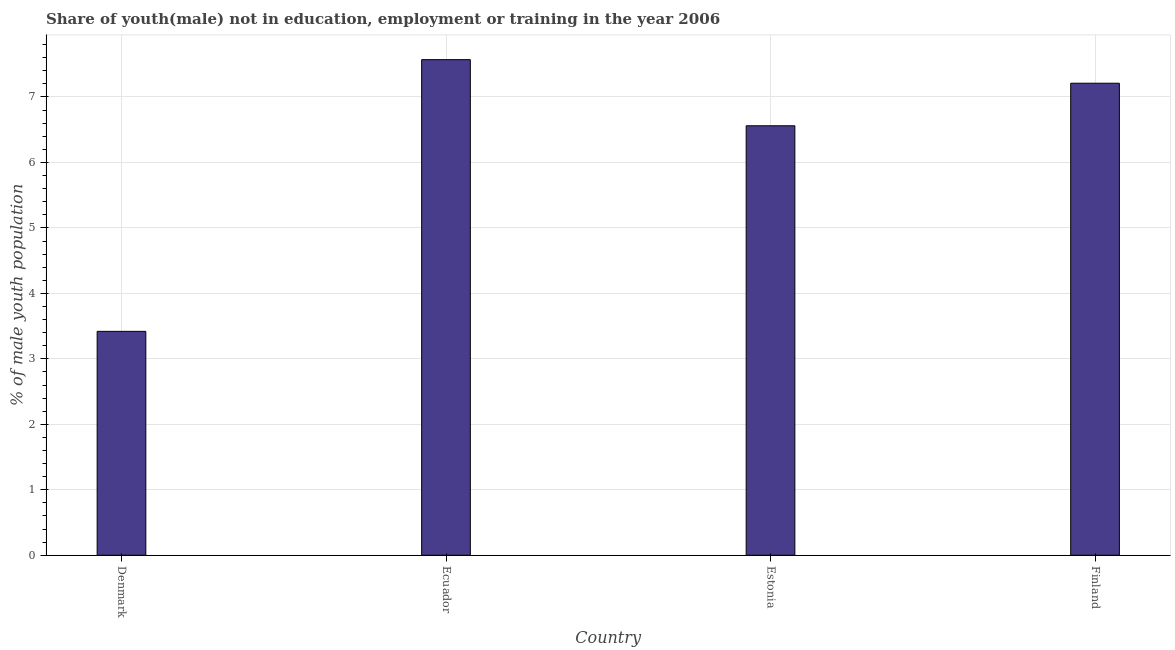Does the graph contain grids?
Give a very brief answer. Yes. What is the title of the graph?
Provide a succinct answer. Share of youth(male) not in education, employment or training in the year 2006. What is the label or title of the X-axis?
Provide a succinct answer. Country. What is the label or title of the Y-axis?
Offer a terse response. % of male youth population. What is the unemployed male youth population in Estonia?
Make the answer very short. 6.56. Across all countries, what is the maximum unemployed male youth population?
Provide a succinct answer. 7.57. Across all countries, what is the minimum unemployed male youth population?
Your answer should be compact. 3.42. In which country was the unemployed male youth population maximum?
Your answer should be compact. Ecuador. In which country was the unemployed male youth population minimum?
Your answer should be compact. Denmark. What is the sum of the unemployed male youth population?
Your response must be concise. 24.76. What is the difference between the unemployed male youth population in Ecuador and Finland?
Ensure brevity in your answer.  0.36. What is the average unemployed male youth population per country?
Offer a very short reply. 6.19. What is the median unemployed male youth population?
Give a very brief answer. 6.88. What is the ratio of the unemployed male youth population in Ecuador to that in Finland?
Keep it short and to the point. 1.05. Is the difference between the unemployed male youth population in Ecuador and Estonia greater than the difference between any two countries?
Your answer should be compact. No. What is the difference between the highest and the second highest unemployed male youth population?
Your answer should be very brief. 0.36. Is the sum of the unemployed male youth population in Ecuador and Finland greater than the maximum unemployed male youth population across all countries?
Your answer should be compact. Yes. What is the difference between the highest and the lowest unemployed male youth population?
Your answer should be compact. 4.15. In how many countries, is the unemployed male youth population greater than the average unemployed male youth population taken over all countries?
Your answer should be very brief. 3. Are the values on the major ticks of Y-axis written in scientific E-notation?
Offer a very short reply. No. What is the % of male youth population in Denmark?
Your answer should be very brief. 3.42. What is the % of male youth population in Ecuador?
Give a very brief answer. 7.57. What is the % of male youth population in Estonia?
Ensure brevity in your answer.  6.56. What is the % of male youth population in Finland?
Offer a terse response. 7.21. What is the difference between the % of male youth population in Denmark and Ecuador?
Your answer should be very brief. -4.15. What is the difference between the % of male youth population in Denmark and Estonia?
Your answer should be very brief. -3.14. What is the difference between the % of male youth population in Denmark and Finland?
Provide a succinct answer. -3.79. What is the difference between the % of male youth population in Ecuador and Estonia?
Your response must be concise. 1.01. What is the difference between the % of male youth population in Ecuador and Finland?
Your answer should be very brief. 0.36. What is the difference between the % of male youth population in Estonia and Finland?
Your response must be concise. -0.65. What is the ratio of the % of male youth population in Denmark to that in Ecuador?
Ensure brevity in your answer.  0.45. What is the ratio of the % of male youth population in Denmark to that in Estonia?
Ensure brevity in your answer.  0.52. What is the ratio of the % of male youth population in Denmark to that in Finland?
Keep it short and to the point. 0.47. What is the ratio of the % of male youth population in Ecuador to that in Estonia?
Make the answer very short. 1.15. What is the ratio of the % of male youth population in Ecuador to that in Finland?
Make the answer very short. 1.05. What is the ratio of the % of male youth population in Estonia to that in Finland?
Your answer should be compact. 0.91. 